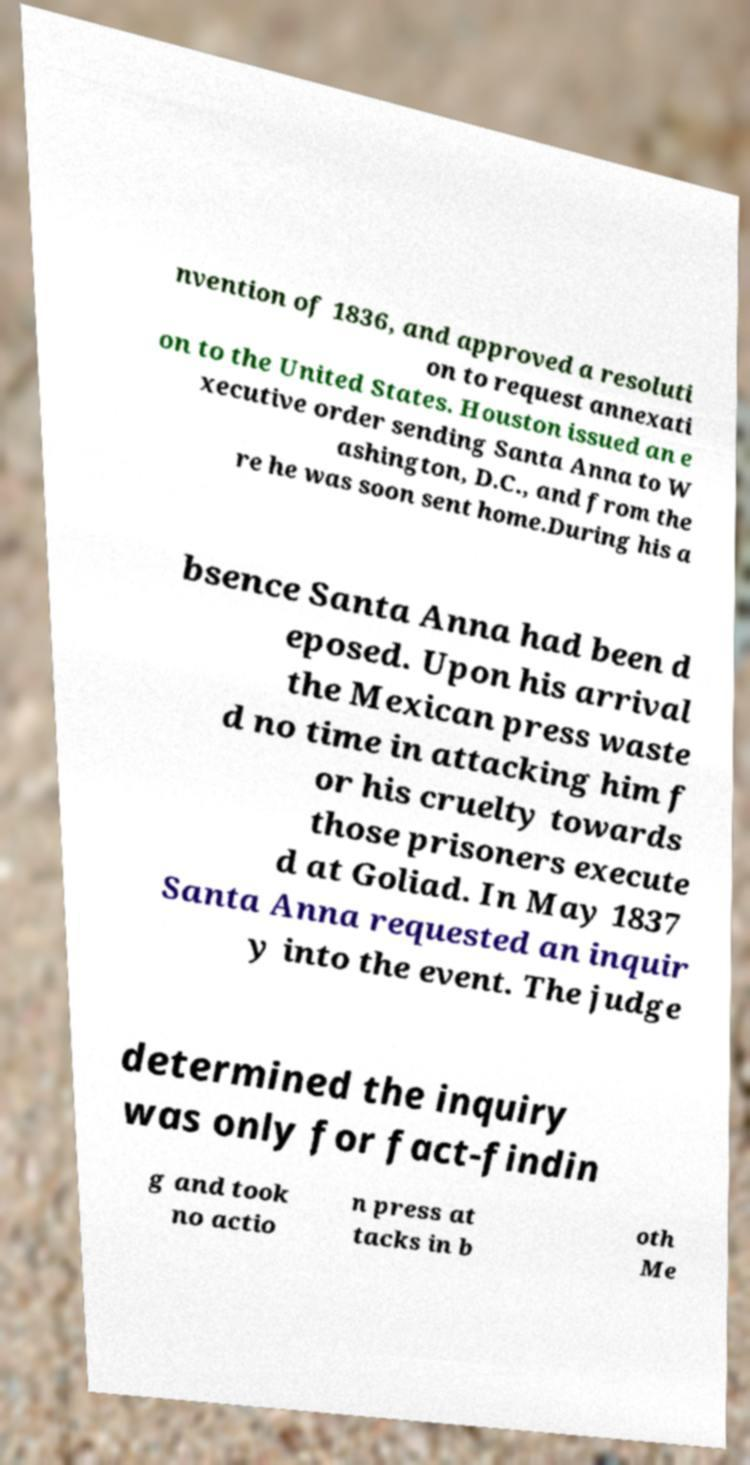Can you read and provide the text displayed in the image?This photo seems to have some interesting text. Can you extract and type it out for me? nvention of 1836, and approved a resoluti on to request annexati on to the United States. Houston issued an e xecutive order sending Santa Anna to W ashington, D.C., and from the re he was soon sent home.During his a bsence Santa Anna had been d eposed. Upon his arrival the Mexican press waste d no time in attacking him f or his cruelty towards those prisoners execute d at Goliad. In May 1837 Santa Anna requested an inquir y into the event. The judge determined the inquiry was only for fact-findin g and took no actio n press at tacks in b oth Me 